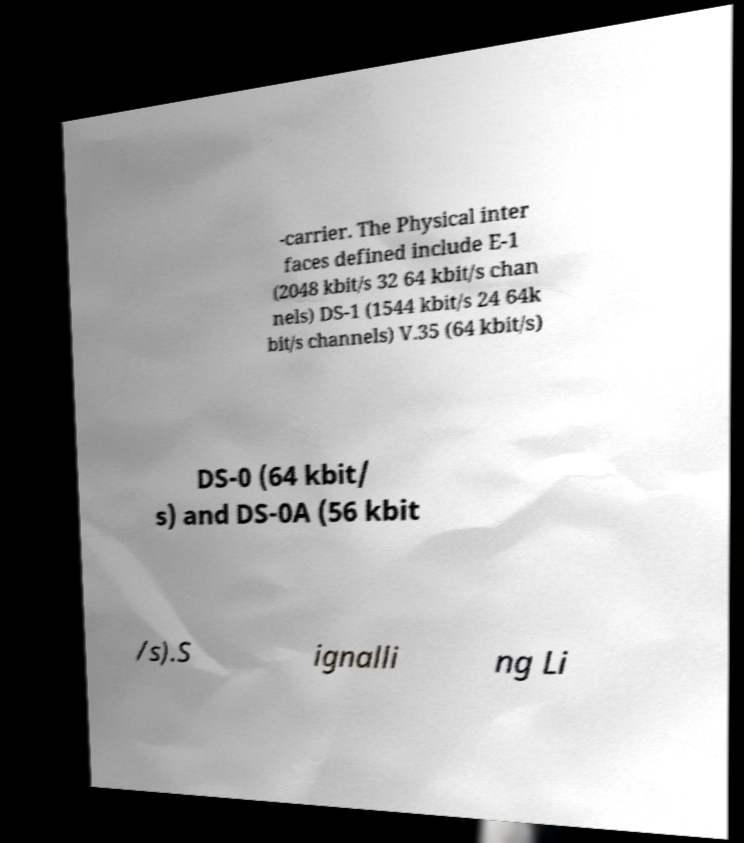What messages or text are displayed in this image? I need them in a readable, typed format. -carrier. The Physical inter faces defined include E-1 (2048 kbit/s 32 64 kbit/s chan nels) DS-1 (1544 kbit/s 24 64k bit/s channels) V.35 (64 kbit/s) DS-0 (64 kbit/ s) and DS-0A (56 kbit /s).S ignalli ng Li 